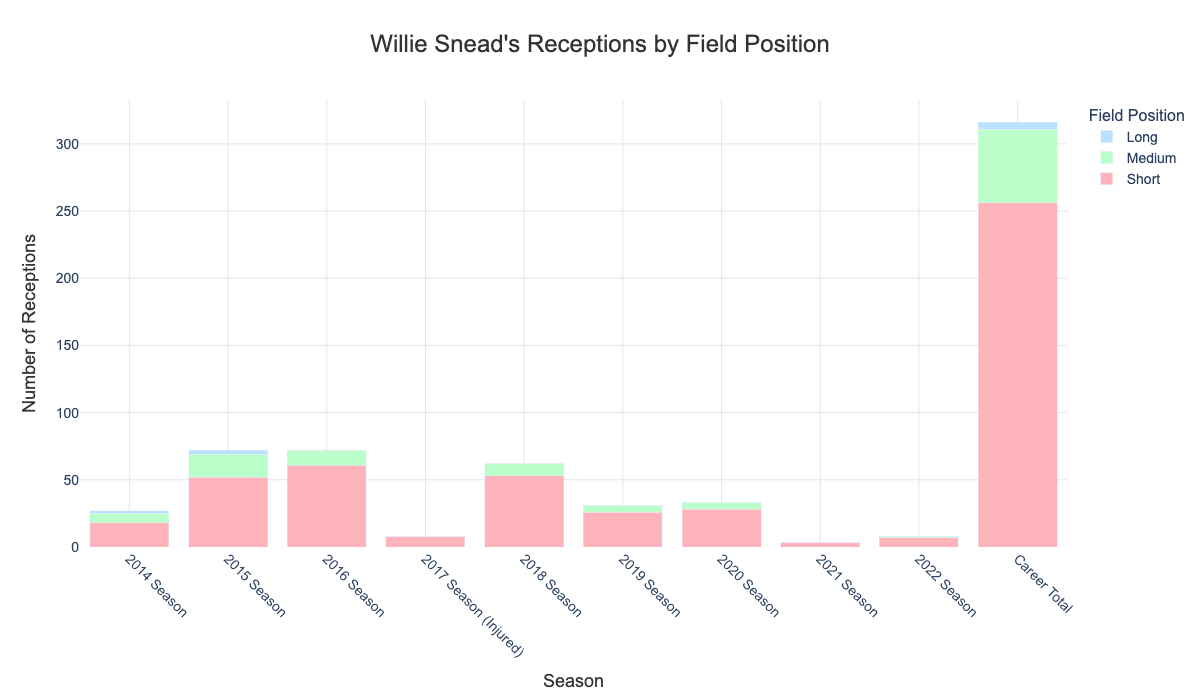What is the total number of short receptions in Willie Snead's 2016 season? To find the total number of short receptions in the 2016 season, look at the bar section corresponding to "2016 Season" for the "Short" category. The figure clearly shows 61 receptions.
Answer: 61 How many total receptions did Willie Snead have in 2015 compared to 2019? Add up the short, medium, and long receptions for both 2015 and 2019: For 2015: 52 (short) + 17 (medium) + 3 (long) = 72; For 2019: 26 (short) + 5 (medium) = 31. So, in 2015 he had more receptions.
Answer: 72 vs. 31 Which season shows the highest number of medium receptions? Compare the medium receptions for each season. The season with the bar with the greatest height for "Medium" will indicate the highest number. Clearly, the 2015 season has the highest number of medium receptions with 17.
Answer: 2015 During which season did Willie Snead have the same number of medium and long receptions? Look for the season where the medium and long reception bars are equal in height. The only season with equal values for medium and long receptions is the 2014 season, with both having 2.
Answer: 2014 How did Willie Snead's total receptions change from the 2018 season to the 2022 season? Calculate the total (short + medium + long) receptions for both 2018 and 2022: For 2018: 53 (short) + 9 (medium) = 62; For 2022: 7 (short) + 1 (medium) = 8. Then determine the difference: 62 - 8 = 54.
Answer: Decreased by 54 Between the seasons 2019 and 2020, in which season did Willie Snead have more short receptions? Directly compare the heights of the "Short" bars for 2019 and 2020. In 2020, the short reception count is 28, higher than 26 in 2019.
Answer: 2020 In which season did Willie Snead achieve his top career receptions regardless of field position? Add up the total receptions for each season and compare. Summing up: 2015 has 52 (short) + 17 (medium) + 3 (long) = 72. This is greater than any other season.
Answer: 2015 Which field position has the overall least number of receptions in Willie Snead's career? Compare the cumulative total of short, medium, and long reception bars across all seasons. The figure shows: Short = 256, Medium = 55, Long = 5. Clearly, long receptions are the fewest.
Answer: Long In how many seasons did Willie Snead record zero long receptions? Check for each season where the height of the "Long" category's bar is zero. These seasons are: 2016, 2017, 2018, 2019, 2020, 2021, 2022. That's 7 seasons in total.
Answer: 7 What's the average number of medium receptions per season over Willie Snead's career? Add up all medium receptions and divide by the number of seasons (excluding "Career Total"): Total mediums: 7+17+11+0+9+5+5+0+1 = 55. Total seasons = 9. Average = 55 / 9 ≈ 6.11. Note: Using approximate result.
Answer: 6.11 